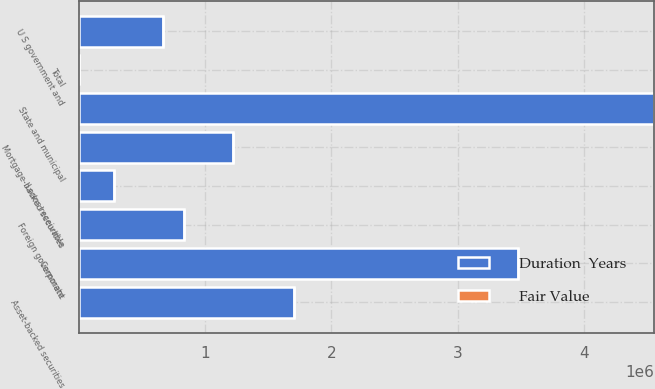Convert chart. <chart><loc_0><loc_0><loc_500><loc_500><stacked_bar_chart><ecel><fcel>U S government and<fcel>State and municipal<fcel>Asset-backed securities<fcel>Corporate<fcel>Foreign government<fcel>Mortgage-backed securities<fcel>Loans receivable<fcel>Total<nl><fcel>Fair Value<fcel>3<fcel>4.5<fcel>1.1<fcel>3.7<fcel>2.7<fcel>3.2<fcel>2.1<fcel>3.3<nl><fcel>Duration  Years<fcel>670419<fcel>4.55355e+06<fcel>1.70517e+06<fcel>3.47504e+06<fcel>837460<fcel>1.2212e+06<fcel>275747<fcel>4.5<nl></chart> 